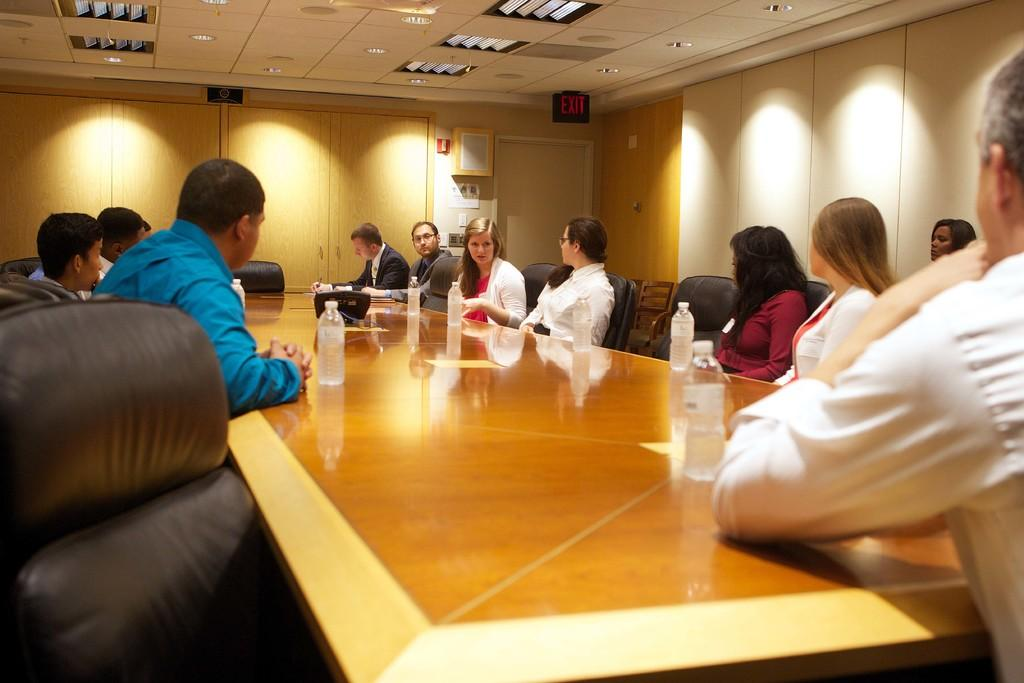What are the persons in the image doing? The persons in the image are sitting on chairs. What can be seen on the tables in the image? There are bottles and other things on the tables. What is visible in the background of the image? There is a wall and a board in the background. What is visible at the top of the image? There are lights visible at the top of the image. Can you tell me how many drains are visible in the image? There are no drains present in the image. What color are the eyes of the person sitting on the left chair? There are no eyes visible in the image, as the persons are not shown in detail. 